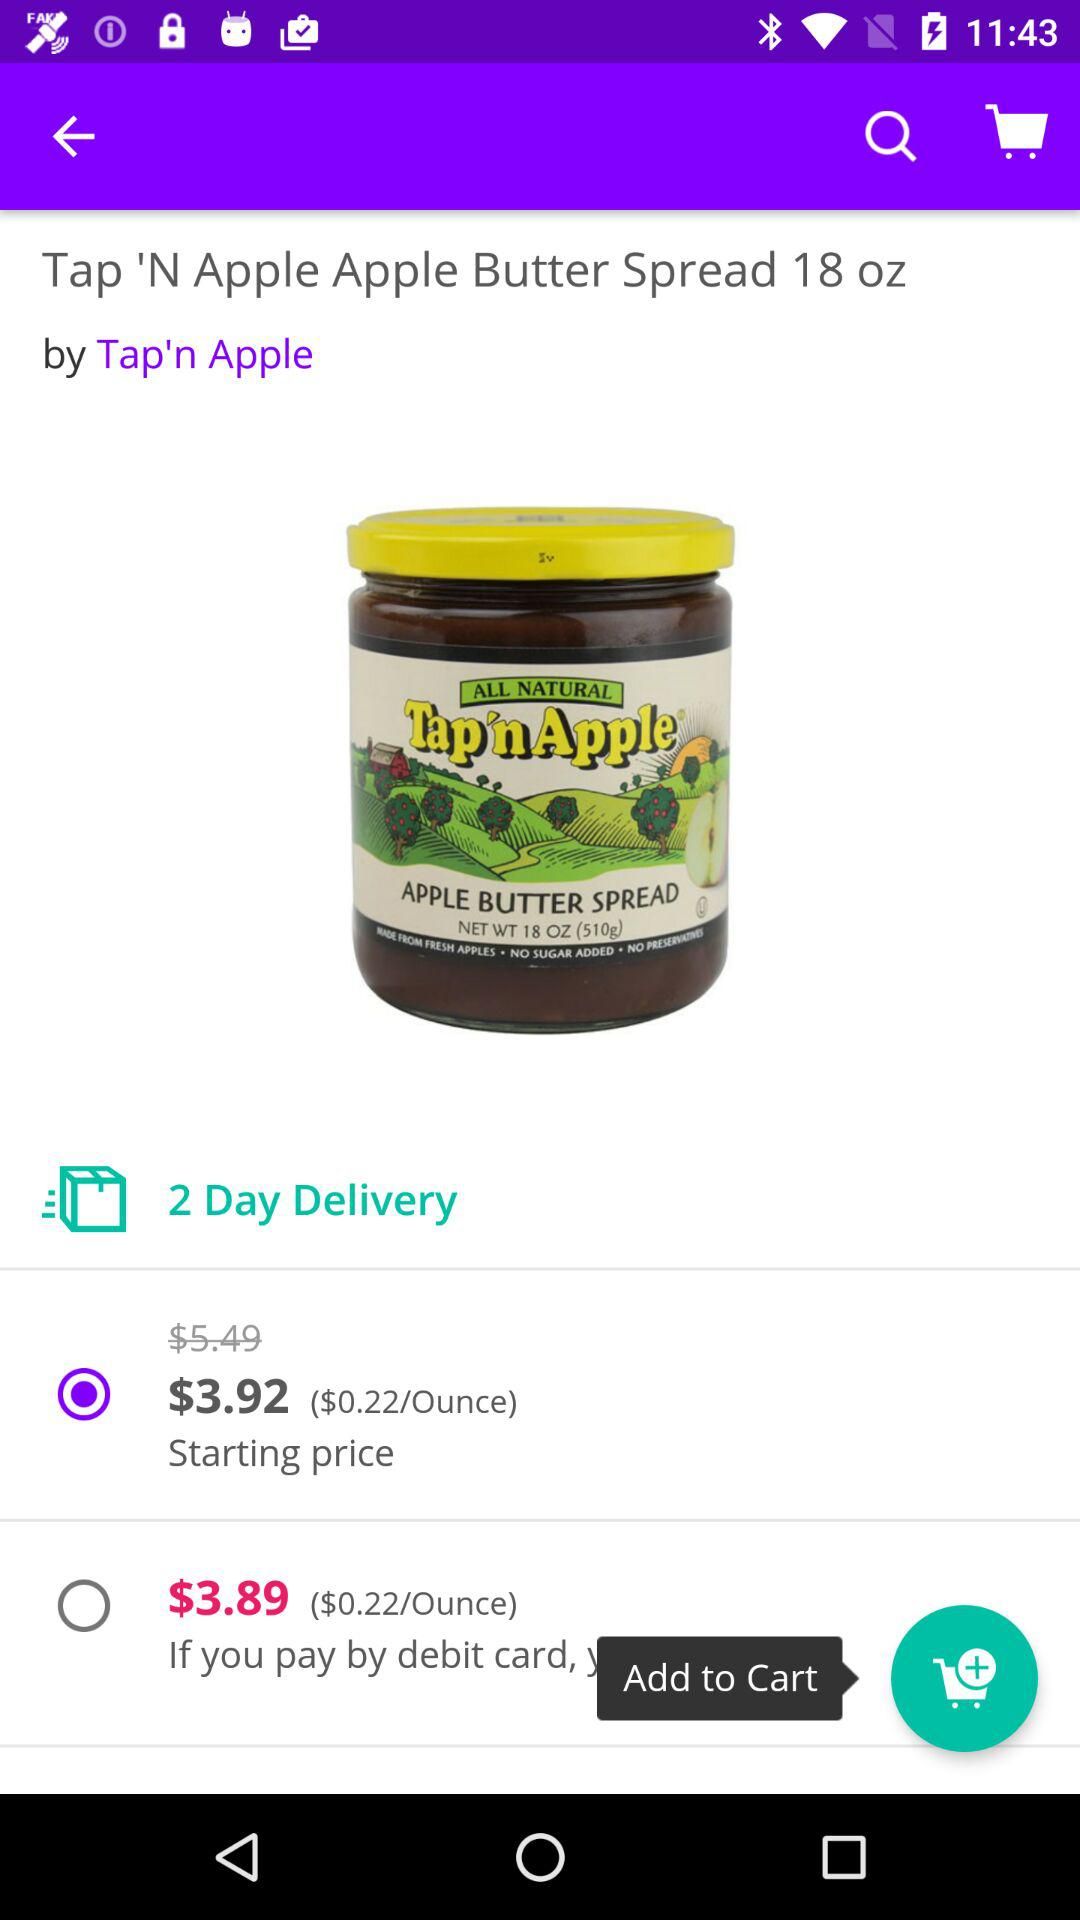What will be the price if users pay by debit card? The price will be $3.89 if users pay by debit card. 